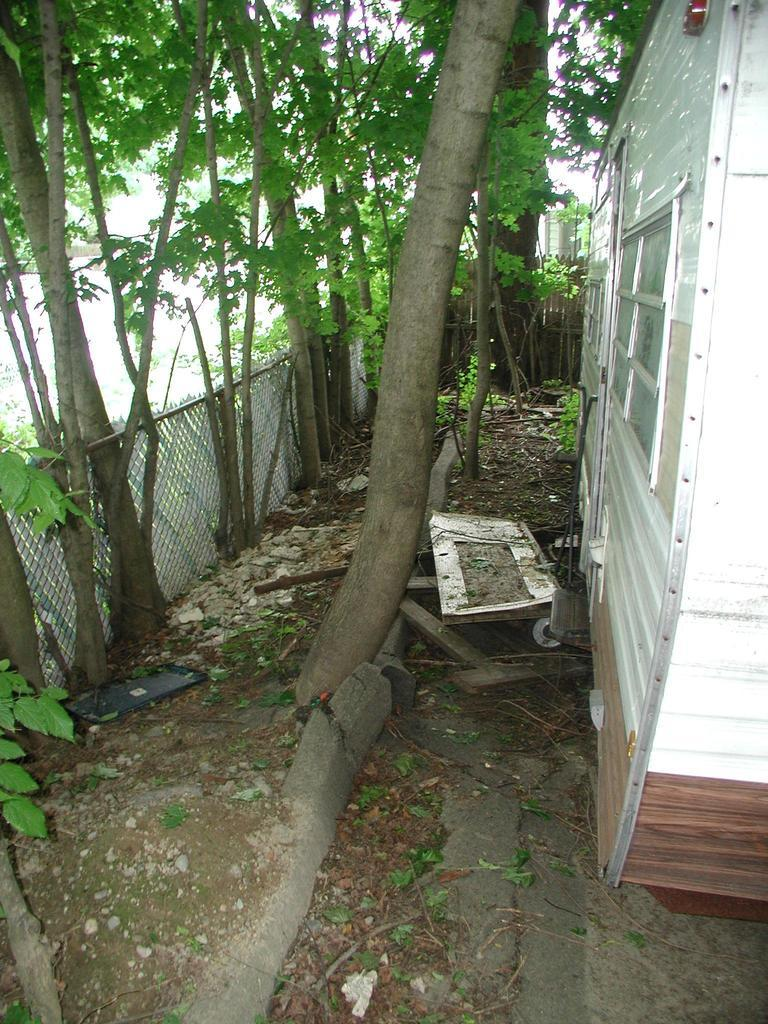What type of outdoor space is shown in the image? There is a backyard in the image. What can be found in the backyard? There are trees in the backyard. How is the backyard separated from other areas? The backyard is separated by fencing. Is there any structure within the backyard? Yes, there is a house in the backyard. How many legs does the spy have in the image? There is no spy present in the image, so it is not possible to determine the number of legs they might have. 